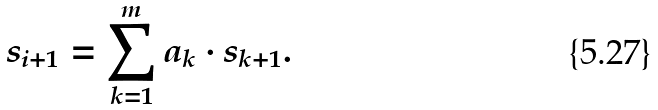<formula> <loc_0><loc_0><loc_500><loc_500>s _ { i + 1 } = \sum _ { k = 1 } ^ { m } a _ { k } \cdot s _ { k + 1 } .</formula> 